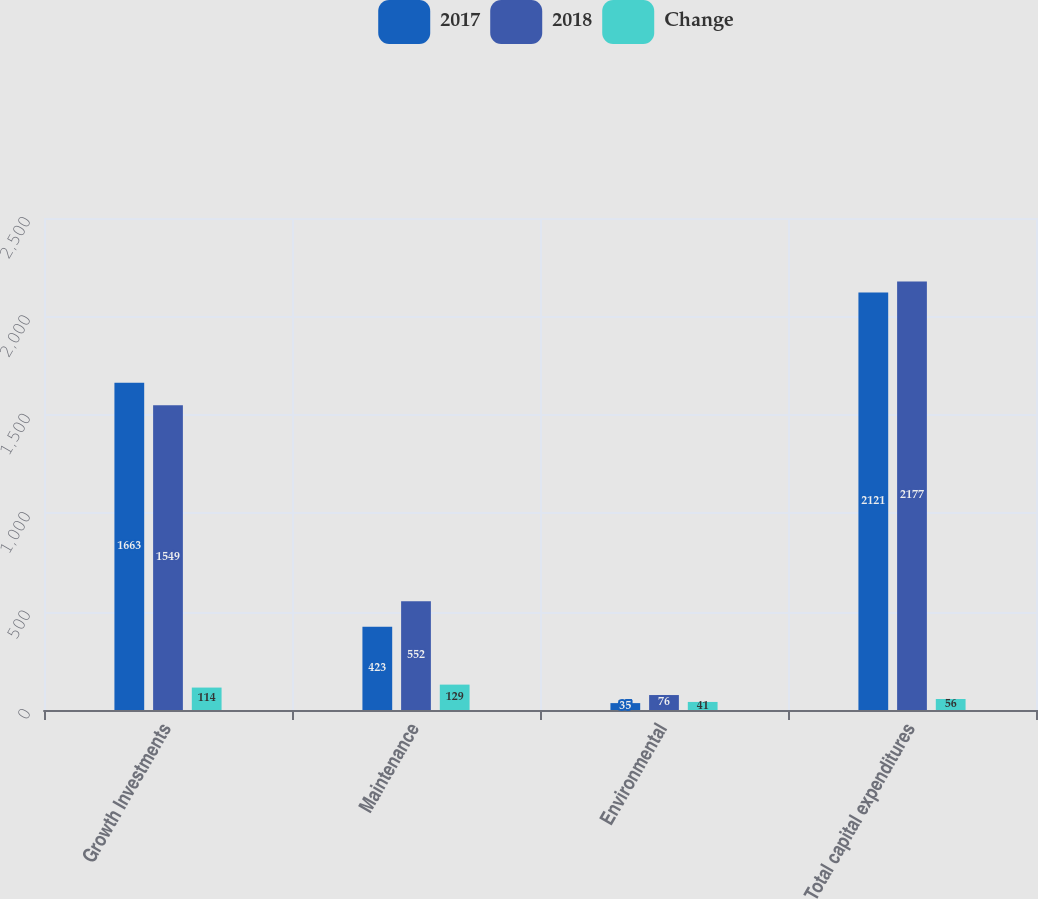<chart> <loc_0><loc_0><loc_500><loc_500><stacked_bar_chart><ecel><fcel>Growth Investments<fcel>Maintenance<fcel>Environmental<fcel>Total capital expenditures<nl><fcel>2017<fcel>1663<fcel>423<fcel>35<fcel>2121<nl><fcel>2018<fcel>1549<fcel>552<fcel>76<fcel>2177<nl><fcel>Change<fcel>114<fcel>129<fcel>41<fcel>56<nl></chart> 